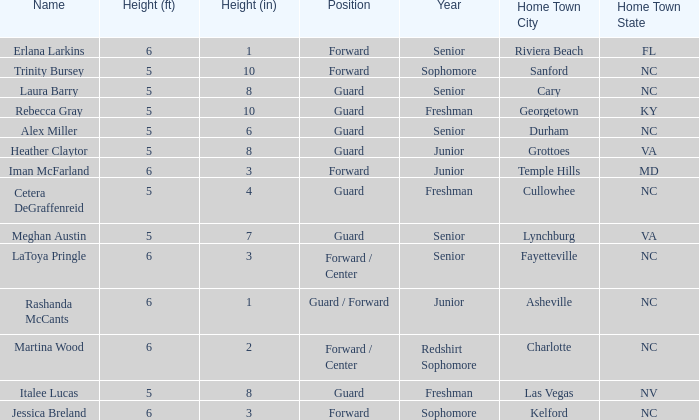Parse the full table. {'header': ['Name', 'Height (ft)', 'Height (in)', 'Position', 'Year', 'Home Town City', 'Home Town State'], 'rows': [['Erlana Larkins', '6', '1', 'Forward', 'Senior', 'Riviera Beach', 'FL'], ['Trinity Bursey', '5', '10', 'Forward', 'Sophomore', 'Sanford', 'NC'], ['Laura Barry', '5', '8', 'Guard', 'Senior', 'Cary', 'NC'], ['Rebecca Gray', '5', '10', 'Guard', 'Freshman', 'Georgetown', 'KY'], ['Alex Miller', '5', '6', 'Guard', 'Senior', 'Durham', 'NC'], ['Heather Claytor', '5', '8', 'Guard', 'Junior', 'Grottoes', 'VA'], ['Iman McFarland', '6', '3', 'Forward', 'Junior', 'Temple Hills', 'MD'], ['Cetera DeGraffenreid', '5', '4', 'Guard', 'Freshman', 'Cullowhee', 'NC'], ['Meghan Austin', '5', '7', 'Guard', 'Senior', 'Lynchburg', 'VA'], ['LaToya Pringle', '6', '3', 'Forward / Center', 'Senior', 'Fayetteville', 'NC'], ['Rashanda McCants', '6', '1', 'Guard / Forward', 'Junior', 'Asheville', 'NC'], ['Martina Wood', '6', '2', 'Forward / Center', 'Redshirt Sophomore', 'Charlotte', 'NC'], ['Italee Lucas', '5', '8', 'Guard', 'Freshman', 'Las Vegas', 'NV'], ['Jessica Breland', '6', '3', 'Forward', 'Sophomore', 'Kelford', 'NC']]} What is the height of the player from Las Vegas, NV? 5-8. 